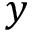Convert formula to latex. <formula><loc_0><loc_0><loc_500><loc_500>y</formula> 